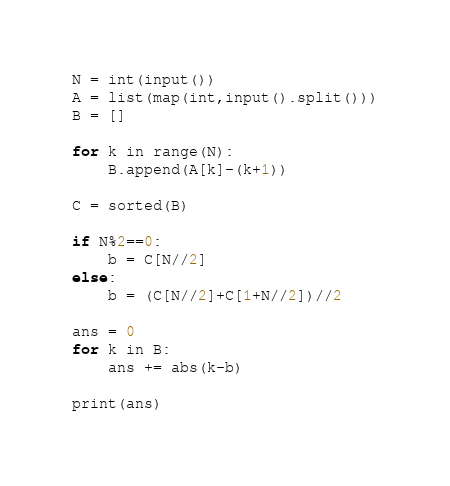<code> <loc_0><loc_0><loc_500><loc_500><_Python_>N = int(input())
A = list(map(int,input().split()))
B = []
 
for k in range(N):
    B.append(A[k]-(k+1))

C = sorted(B)

if N%2==0:
    b = C[N//2]
else:
    b = (C[N//2]+C[1+N//2])//2

ans = 0
for k in B:
    ans += abs(k-b)

print(ans)</code> 